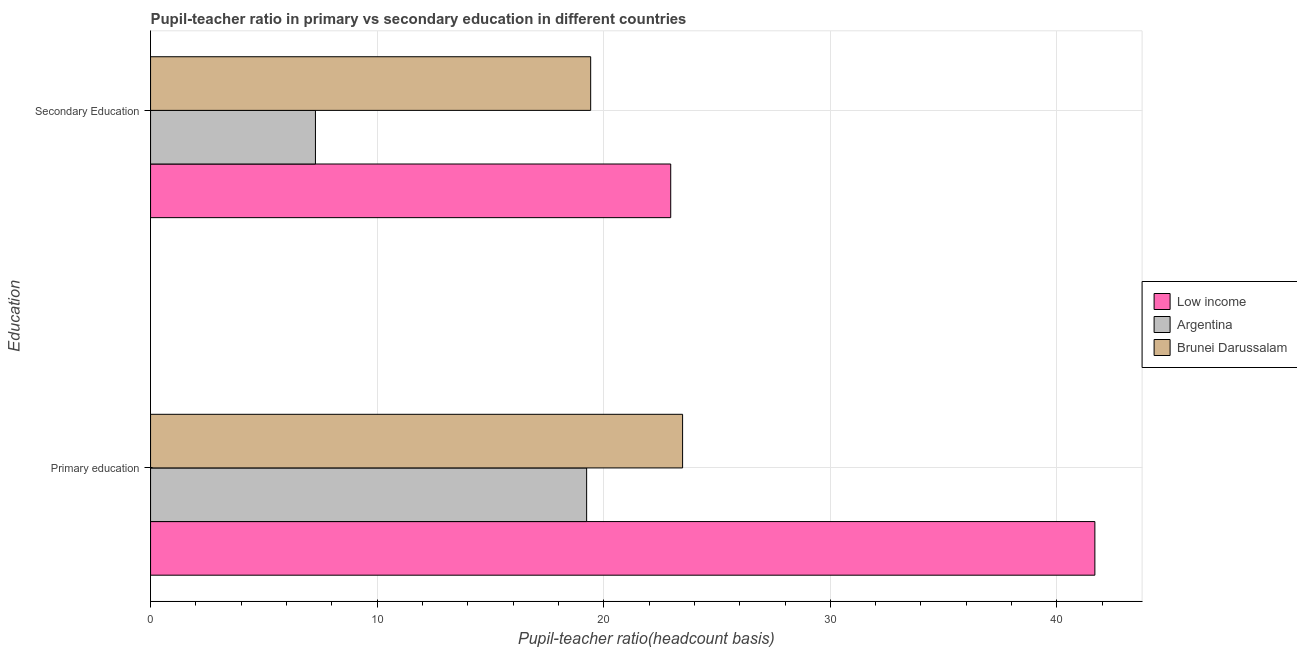How many groups of bars are there?
Provide a short and direct response. 2. How many bars are there on the 2nd tick from the top?
Give a very brief answer. 3. What is the pupil-teacher ratio in primary education in Argentina?
Provide a short and direct response. 19.25. Across all countries, what is the maximum pupil teacher ratio on secondary education?
Offer a terse response. 22.96. Across all countries, what is the minimum pupil teacher ratio on secondary education?
Offer a terse response. 7.28. In which country was the pupil-teacher ratio in primary education maximum?
Offer a very short reply. Low income. What is the total pupil teacher ratio on secondary education in the graph?
Offer a terse response. 49.66. What is the difference between the pupil teacher ratio on secondary education in Argentina and that in Brunei Darussalam?
Offer a very short reply. -12.15. What is the difference between the pupil teacher ratio on secondary education in Low income and the pupil-teacher ratio in primary education in Argentina?
Ensure brevity in your answer.  3.71. What is the average pupil-teacher ratio in primary education per country?
Ensure brevity in your answer.  28.13. What is the difference between the pupil teacher ratio on secondary education and pupil-teacher ratio in primary education in Argentina?
Your answer should be very brief. -11.97. What is the ratio of the pupil teacher ratio on secondary education in Argentina to that in Low income?
Provide a short and direct response. 0.32. In how many countries, is the pupil-teacher ratio in primary education greater than the average pupil-teacher ratio in primary education taken over all countries?
Keep it short and to the point. 1. What does the 2nd bar from the top in Secondary Education represents?
Your answer should be very brief. Argentina. What does the 1st bar from the bottom in Primary education represents?
Your answer should be very brief. Low income. Are all the bars in the graph horizontal?
Keep it short and to the point. Yes. What is the difference between two consecutive major ticks on the X-axis?
Keep it short and to the point. 10. Does the graph contain grids?
Your response must be concise. Yes. How are the legend labels stacked?
Offer a very short reply. Vertical. What is the title of the graph?
Offer a very short reply. Pupil-teacher ratio in primary vs secondary education in different countries. What is the label or title of the X-axis?
Offer a very short reply. Pupil-teacher ratio(headcount basis). What is the label or title of the Y-axis?
Keep it short and to the point. Education. What is the Pupil-teacher ratio(headcount basis) in Low income in Primary education?
Offer a very short reply. 41.68. What is the Pupil-teacher ratio(headcount basis) in Argentina in Primary education?
Provide a short and direct response. 19.25. What is the Pupil-teacher ratio(headcount basis) in Brunei Darussalam in Primary education?
Your answer should be compact. 23.48. What is the Pupil-teacher ratio(headcount basis) of Low income in Secondary Education?
Provide a short and direct response. 22.96. What is the Pupil-teacher ratio(headcount basis) of Argentina in Secondary Education?
Provide a short and direct response. 7.28. What is the Pupil-teacher ratio(headcount basis) in Brunei Darussalam in Secondary Education?
Provide a short and direct response. 19.42. Across all Education, what is the maximum Pupil-teacher ratio(headcount basis) of Low income?
Give a very brief answer. 41.68. Across all Education, what is the maximum Pupil-teacher ratio(headcount basis) of Argentina?
Make the answer very short. 19.25. Across all Education, what is the maximum Pupil-teacher ratio(headcount basis) in Brunei Darussalam?
Your answer should be compact. 23.48. Across all Education, what is the minimum Pupil-teacher ratio(headcount basis) of Low income?
Provide a short and direct response. 22.96. Across all Education, what is the minimum Pupil-teacher ratio(headcount basis) in Argentina?
Offer a terse response. 7.28. Across all Education, what is the minimum Pupil-teacher ratio(headcount basis) of Brunei Darussalam?
Your response must be concise. 19.42. What is the total Pupil-teacher ratio(headcount basis) in Low income in the graph?
Your answer should be very brief. 64.63. What is the total Pupil-teacher ratio(headcount basis) in Argentina in the graph?
Make the answer very short. 26.52. What is the total Pupil-teacher ratio(headcount basis) of Brunei Darussalam in the graph?
Ensure brevity in your answer.  42.9. What is the difference between the Pupil-teacher ratio(headcount basis) in Low income in Primary education and that in Secondary Education?
Your answer should be compact. 18.72. What is the difference between the Pupil-teacher ratio(headcount basis) of Argentina in Primary education and that in Secondary Education?
Keep it short and to the point. 11.97. What is the difference between the Pupil-teacher ratio(headcount basis) in Brunei Darussalam in Primary education and that in Secondary Education?
Your response must be concise. 4.06. What is the difference between the Pupil-teacher ratio(headcount basis) of Low income in Primary education and the Pupil-teacher ratio(headcount basis) of Argentina in Secondary Education?
Provide a succinct answer. 34.4. What is the difference between the Pupil-teacher ratio(headcount basis) in Low income in Primary education and the Pupil-teacher ratio(headcount basis) in Brunei Darussalam in Secondary Education?
Offer a terse response. 22.25. What is the difference between the Pupil-teacher ratio(headcount basis) in Argentina in Primary education and the Pupil-teacher ratio(headcount basis) in Brunei Darussalam in Secondary Education?
Your answer should be compact. -0.18. What is the average Pupil-teacher ratio(headcount basis) in Low income per Education?
Provide a succinct answer. 32.32. What is the average Pupil-teacher ratio(headcount basis) in Argentina per Education?
Provide a short and direct response. 13.26. What is the average Pupil-teacher ratio(headcount basis) of Brunei Darussalam per Education?
Keep it short and to the point. 21.45. What is the difference between the Pupil-teacher ratio(headcount basis) in Low income and Pupil-teacher ratio(headcount basis) in Argentina in Primary education?
Your answer should be compact. 22.43. What is the difference between the Pupil-teacher ratio(headcount basis) of Low income and Pupil-teacher ratio(headcount basis) of Brunei Darussalam in Primary education?
Provide a succinct answer. 18.2. What is the difference between the Pupil-teacher ratio(headcount basis) of Argentina and Pupil-teacher ratio(headcount basis) of Brunei Darussalam in Primary education?
Your answer should be very brief. -4.23. What is the difference between the Pupil-teacher ratio(headcount basis) in Low income and Pupil-teacher ratio(headcount basis) in Argentina in Secondary Education?
Your answer should be very brief. 15.68. What is the difference between the Pupil-teacher ratio(headcount basis) in Low income and Pupil-teacher ratio(headcount basis) in Brunei Darussalam in Secondary Education?
Offer a very short reply. 3.53. What is the difference between the Pupil-teacher ratio(headcount basis) in Argentina and Pupil-teacher ratio(headcount basis) in Brunei Darussalam in Secondary Education?
Provide a short and direct response. -12.15. What is the ratio of the Pupil-teacher ratio(headcount basis) of Low income in Primary education to that in Secondary Education?
Give a very brief answer. 1.82. What is the ratio of the Pupil-teacher ratio(headcount basis) of Argentina in Primary education to that in Secondary Education?
Offer a terse response. 2.64. What is the ratio of the Pupil-teacher ratio(headcount basis) in Brunei Darussalam in Primary education to that in Secondary Education?
Give a very brief answer. 1.21. What is the difference between the highest and the second highest Pupil-teacher ratio(headcount basis) of Low income?
Ensure brevity in your answer.  18.72. What is the difference between the highest and the second highest Pupil-teacher ratio(headcount basis) in Argentina?
Keep it short and to the point. 11.97. What is the difference between the highest and the second highest Pupil-teacher ratio(headcount basis) in Brunei Darussalam?
Provide a succinct answer. 4.06. What is the difference between the highest and the lowest Pupil-teacher ratio(headcount basis) in Low income?
Your response must be concise. 18.72. What is the difference between the highest and the lowest Pupil-teacher ratio(headcount basis) of Argentina?
Offer a terse response. 11.97. What is the difference between the highest and the lowest Pupil-teacher ratio(headcount basis) in Brunei Darussalam?
Offer a terse response. 4.06. 